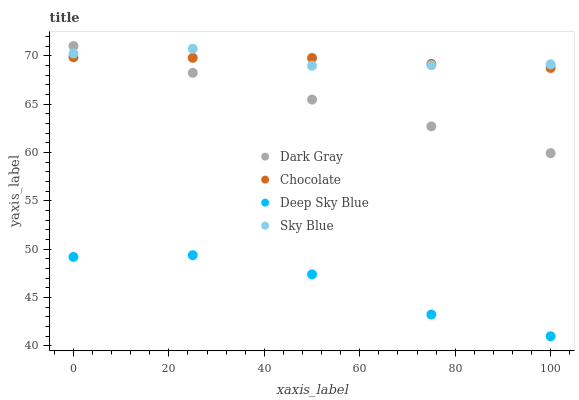Does Deep Sky Blue have the minimum area under the curve?
Answer yes or no. Yes. Does Sky Blue have the maximum area under the curve?
Answer yes or no. Yes. Does Sky Blue have the minimum area under the curve?
Answer yes or no. No. Does Deep Sky Blue have the maximum area under the curve?
Answer yes or no. No. Is Dark Gray the smoothest?
Answer yes or no. Yes. Is Deep Sky Blue the roughest?
Answer yes or no. Yes. Is Sky Blue the smoothest?
Answer yes or no. No. Is Sky Blue the roughest?
Answer yes or no. No. Does Deep Sky Blue have the lowest value?
Answer yes or no. Yes. Does Sky Blue have the lowest value?
Answer yes or no. No. Does Dark Gray have the highest value?
Answer yes or no. Yes. Does Sky Blue have the highest value?
Answer yes or no. No. Is Deep Sky Blue less than Sky Blue?
Answer yes or no. Yes. Is Chocolate greater than Deep Sky Blue?
Answer yes or no. Yes. Does Dark Gray intersect Sky Blue?
Answer yes or no. Yes. Is Dark Gray less than Sky Blue?
Answer yes or no. No. Is Dark Gray greater than Sky Blue?
Answer yes or no. No. Does Deep Sky Blue intersect Sky Blue?
Answer yes or no. No. 